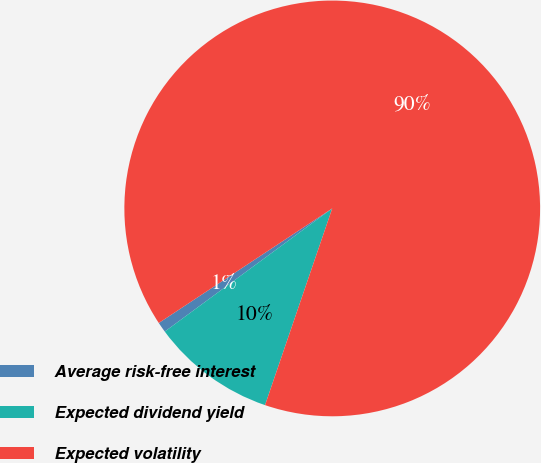Convert chart to OTSL. <chart><loc_0><loc_0><loc_500><loc_500><pie_chart><fcel>Average risk-free interest<fcel>Expected dividend yield<fcel>Expected volatility<nl><fcel>0.8%<fcel>9.67%<fcel>89.53%<nl></chart> 